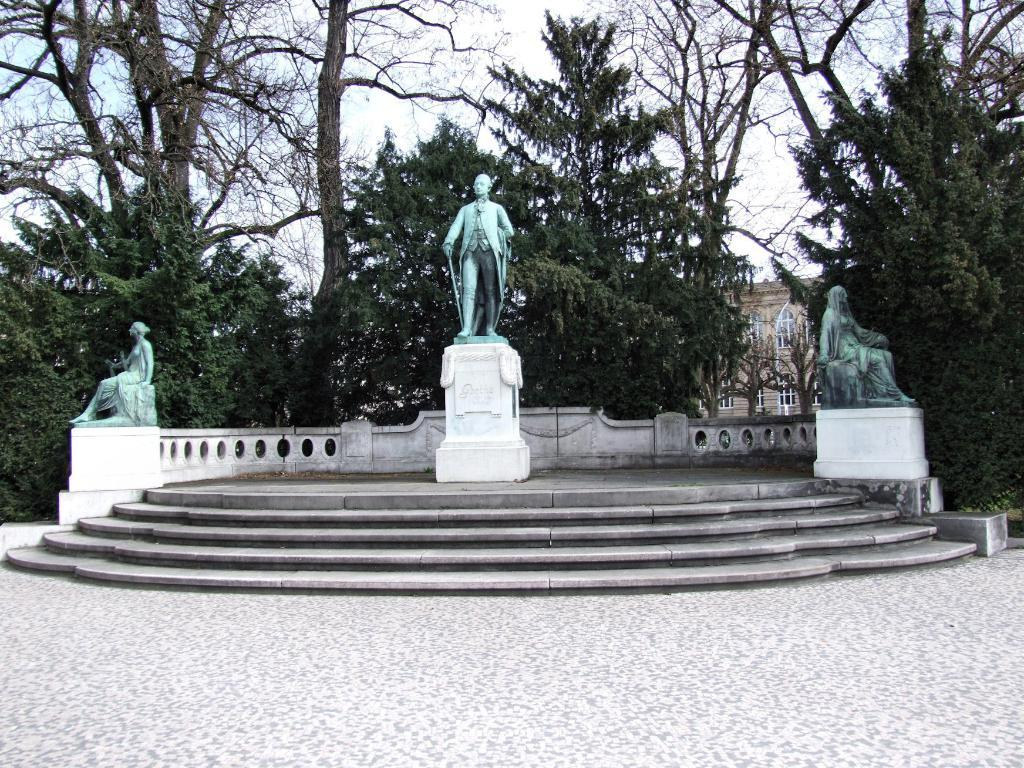What type of structure can be seen in the image? There are stairs in the image. What is located in the front of the image? There are three sculptures in the front of the image. What can be seen in the background of the image? There are trees, a building, and the sky visible in the background of the image. How many cars are parked on the shelf in the image? There are no cars or shelves present in the image. 